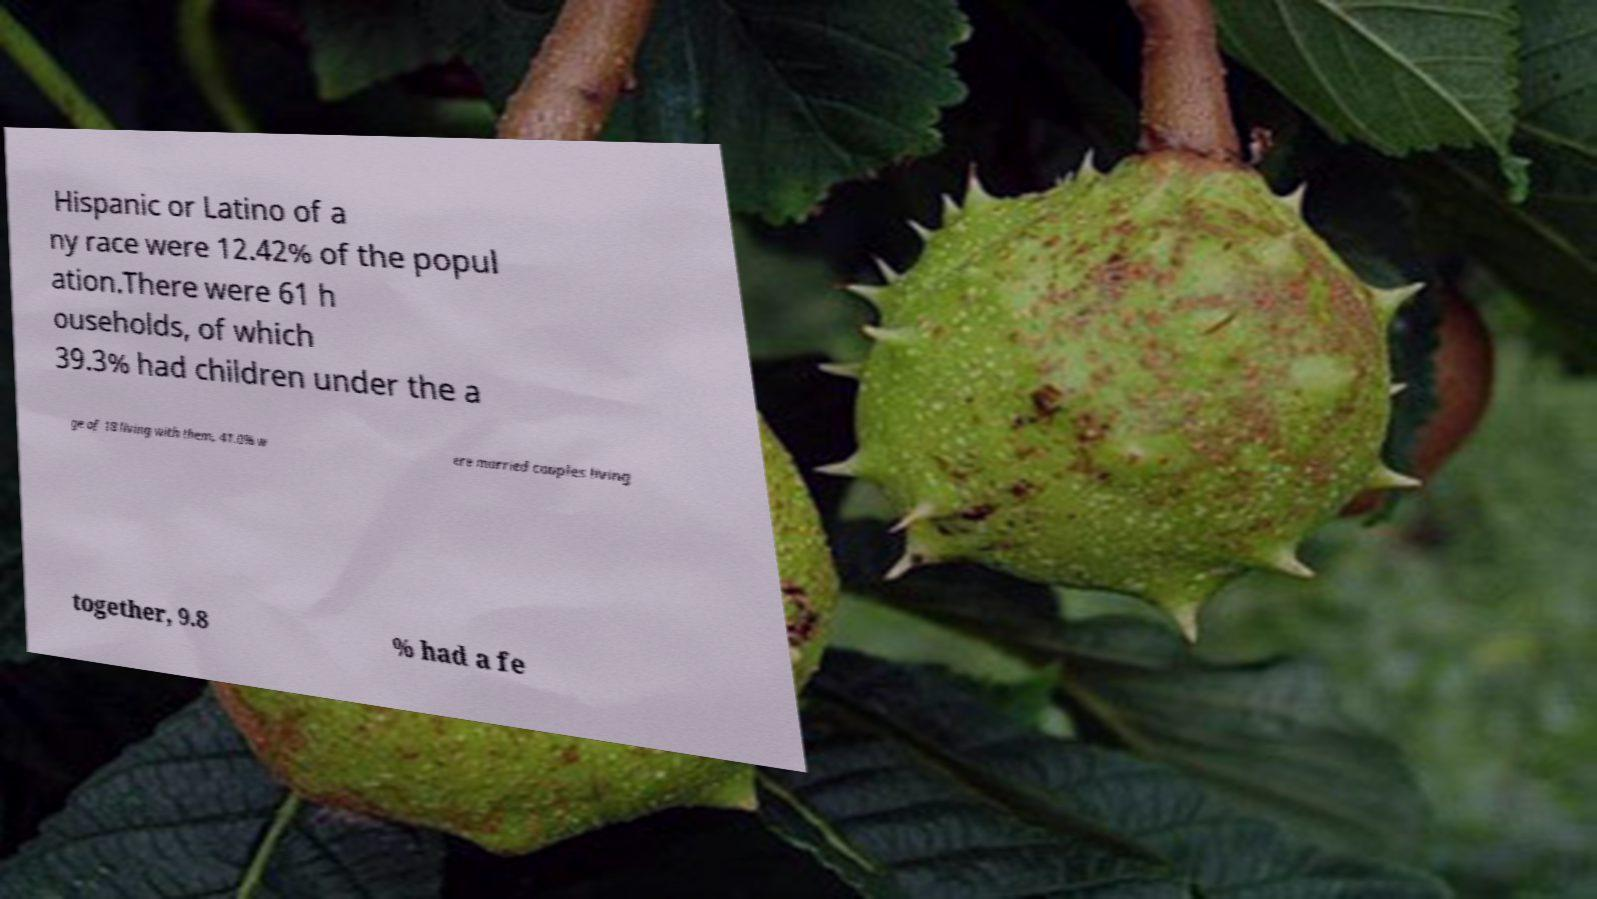Could you assist in decoding the text presented in this image and type it out clearly? Hispanic or Latino of a ny race were 12.42% of the popul ation.There were 61 h ouseholds, of which 39.3% had children under the a ge of 18 living with them, 41.0% w ere married couples living together, 9.8 % had a fe 